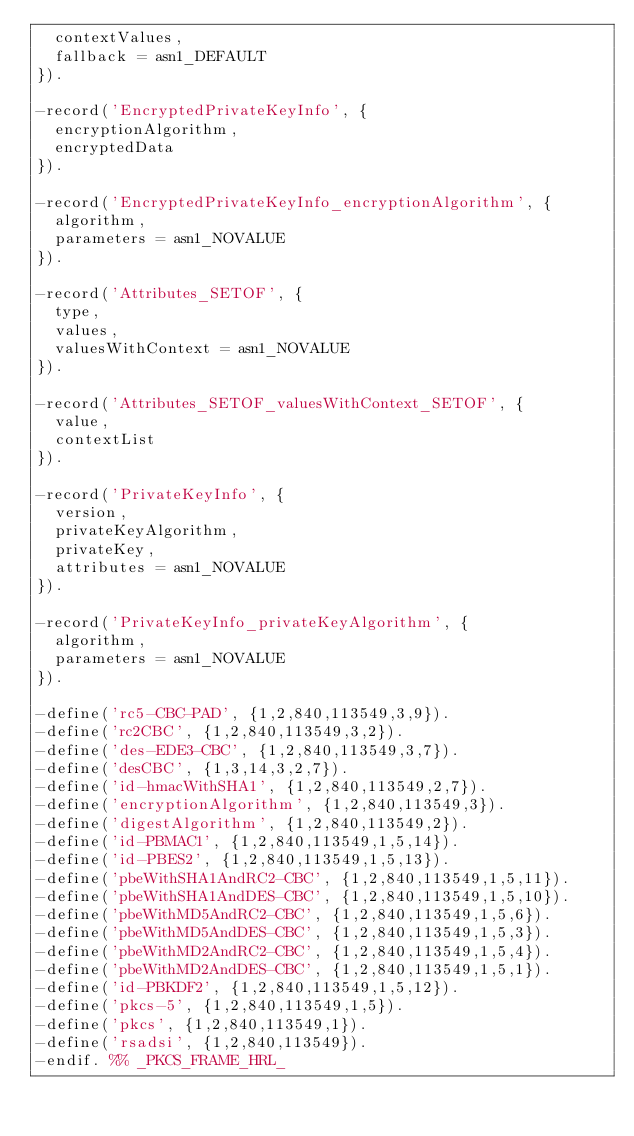Convert code to text. <code><loc_0><loc_0><loc_500><loc_500><_Erlang_>  contextValues,
  fallback = asn1_DEFAULT
}).

-record('EncryptedPrivateKeyInfo', {
  encryptionAlgorithm,
  encryptedData
}).

-record('EncryptedPrivateKeyInfo_encryptionAlgorithm', {
  algorithm,
  parameters = asn1_NOVALUE
}).

-record('Attributes_SETOF', {
  type,
  values,
  valuesWithContext = asn1_NOVALUE
}).

-record('Attributes_SETOF_valuesWithContext_SETOF', {
  value,
  contextList
}).

-record('PrivateKeyInfo', {
  version,
  privateKeyAlgorithm,
  privateKey,
  attributes = asn1_NOVALUE
}).

-record('PrivateKeyInfo_privateKeyAlgorithm', {
  algorithm,
  parameters = asn1_NOVALUE
}).

-define('rc5-CBC-PAD', {1,2,840,113549,3,9}).
-define('rc2CBC', {1,2,840,113549,3,2}).
-define('des-EDE3-CBC', {1,2,840,113549,3,7}).
-define('desCBC', {1,3,14,3,2,7}).
-define('id-hmacWithSHA1', {1,2,840,113549,2,7}).
-define('encryptionAlgorithm', {1,2,840,113549,3}).
-define('digestAlgorithm', {1,2,840,113549,2}).
-define('id-PBMAC1', {1,2,840,113549,1,5,14}).
-define('id-PBES2', {1,2,840,113549,1,5,13}).
-define('pbeWithSHA1AndRC2-CBC', {1,2,840,113549,1,5,11}).
-define('pbeWithSHA1AndDES-CBC', {1,2,840,113549,1,5,10}).
-define('pbeWithMD5AndRC2-CBC', {1,2,840,113549,1,5,6}).
-define('pbeWithMD5AndDES-CBC', {1,2,840,113549,1,5,3}).
-define('pbeWithMD2AndRC2-CBC', {1,2,840,113549,1,5,4}).
-define('pbeWithMD2AndDES-CBC', {1,2,840,113549,1,5,1}).
-define('id-PBKDF2', {1,2,840,113549,1,5,12}).
-define('pkcs-5', {1,2,840,113549,1,5}).
-define('pkcs', {1,2,840,113549,1}).
-define('rsadsi', {1,2,840,113549}).
-endif. %% _PKCS_FRAME_HRL_
</code> 